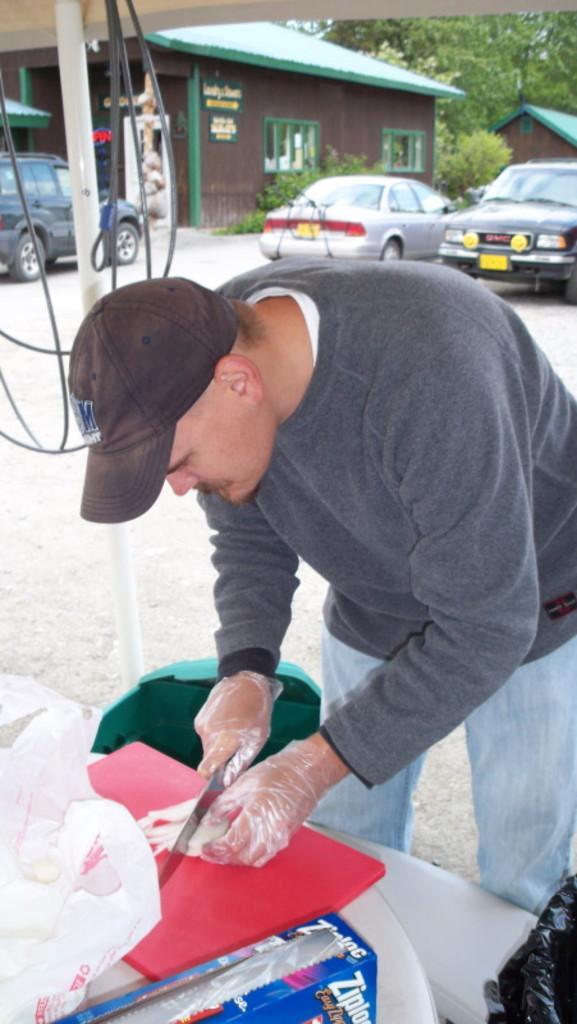Could you give a brief overview of what you see in this image? In this image we can see this person wearing cap, black color T-shirt and shoes is standing here and holding a knife and cutting some objects. Here we can see few objects are kept, we can see trash can, wires, few cars parked here, wooden house and trees in the background. 